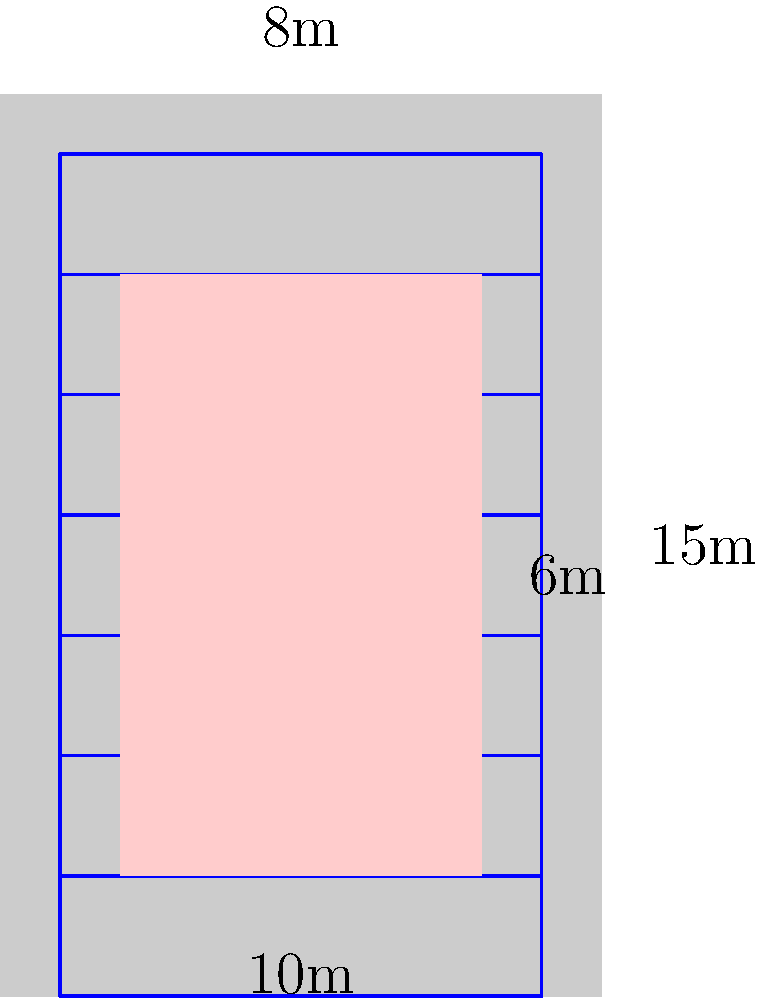You're supporting an artist by allowing them to paint a mural on your building. The building is 15m tall, and the mural will cover an area 10m wide by 12m high. Scaffolding rental costs $5 per square meter per day. If the artist estimates it will take 7 days to complete the mural, what will be the total cost of scaffolding rental? To calculate the total cost of scaffolding rental, we need to follow these steps:

1. Calculate the area of scaffolding required:
   - The scaffolding needs to cover the full height of the building (15m) and the width of the mural (10m).
   - Area of scaffolding = $15\text{m} \times 10\text{m} = 150\text{m}^2$

2. Calculate the daily rental cost:
   - Cost per square meter per day = $5
   - Daily rental cost = $150\text{m}^2 \times \$5/\text{m}^2 = \$750$ per day

3. Calculate the total rental cost for 7 days:
   - Total cost = Daily rental cost $\times$ Number of days
   - Total cost = $\$750 \times 7 = \$5,250$

Therefore, the total cost of scaffolding rental for the 7-day mural project will be $5,250.
Answer: $5,250 